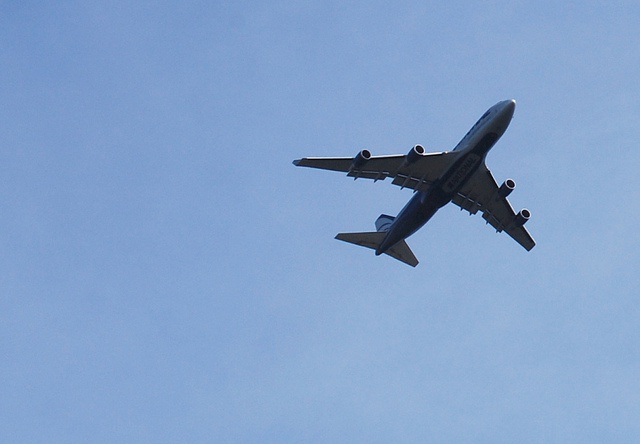Describe the objects in this image and their specific colors. I can see a airplane in gray, black, darkblue, and lightblue tones in this image. 